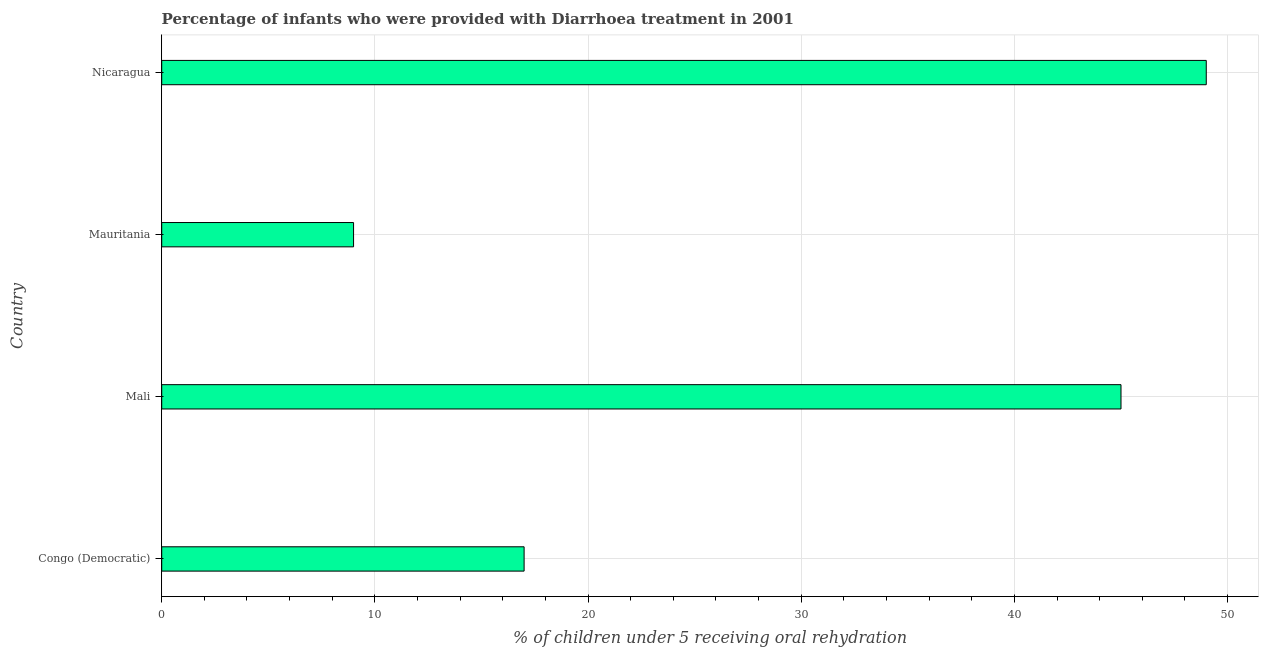What is the title of the graph?
Ensure brevity in your answer.  Percentage of infants who were provided with Diarrhoea treatment in 2001. What is the label or title of the X-axis?
Keep it short and to the point. % of children under 5 receiving oral rehydration. Across all countries, what is the maximum percentage of children who were provided with treatment diarrhoea?
Your answer should be compact. 49. Across all countries, what is the minimum percentage of children who were provided with treatment diarrhoea?
Keep it short and to the point. 9. In which country was the percentage of children who were provided with treatment diarrhoea maximum?
Offer a very short reply. Nicaragua. In which country was the percentage of children who were provided with treatment diarrhoea minimum?
Ensure brevity in your answer.  Mauritania. What is the sum of the percentage of children who were provided with treatment diarrhoea?
Your answer should be very brief. 120. What is the difference between the percentage of children who were provided with treatment diarrhoea in Congo (Democratic) and Nicaragua?
Provide a succinct answer. -32. What is the average percentage of children who were provided with treatment diarrhoea per country?
Make the answer very short. 30. What is the median percentage of children who were provided with treatment diarrhoea?
Make the answer very short. 31. In how many countries, is the percentage of children who were provided with treatment diarrhoea greater than 30 %?
Provide a succinct answer. 2. What is the ratio of the percentage of children who were provided with treatment diarrhoea in Mali to that in Nicaragua?
Keep it short and to the point. 0.92. Is the percentage of children who were provided with treatment diarrhoea in Congo (Democratic) less than that in Mauritania?
Offer a very short reply. No. Is the difference between the percentage of children who were provided with treatment diarrhoea in Congo (Democratic) and Mali greater than the difference between any two countries?
Offer a very short reply. No. What is the difference between the highest and the second highest percentage of children who were provided with treatment diarrhoea?
Provide a short and direct response. 4. How many bars are there?
Your answer should be very brief. 4. Are all the bars in the graph horizontal?
Offer a terse response. Yes. Are the values on the major ticks of X-axis written in scientific E-notation?
Offer a terse response. No. What is the % of children under 5 receiving oral rehydration in Congo (Democratic)?
Make the answer very short. 17. What is the % of children under 5 receiving oral rehydration of Mali?
Provide a short and direct response. 45. What is the difference between the % of children under 5 receiving oral rehydration in Congo (Democratic) and Mali?
Provide a succinct answer. -28. What is the difference between the % of children under 5 receiving oral rehydration in Congo (Democratic) and Mauritania?
Your answer should be compact. 8. What is the difference between the % of children under 5 receiving oral rehydration in Congo (Democratic) and Nicaragua?
Your answer should be compact. -32. What is the difference between the % of children under 5 receiving oral rehydration in Mali and Mauritania?
Your response must be concise. 36. What is the ratio of the % of children under 5 receiving oral rehydration in Congo (Democratic) to that in Mali?
Your answer should be very brief. 0.38. What is the ratio of the % of children under 5 receiving oral rehydration in Congo (Democratic) to that in Mauritania?
Provide a short and direct response. 1.89. What is the ratio of the % of children under 5 receiving oral rehydration in Congo (Democratic) to that in Nicaragua?
Your answer should be very brief. 0.35. What is the ratio of the % of children under 5 receiving oral rehydration in Mali to that in Nicaragua?
Keep it short and to the point. 0.92. What is the ratio of the % of children under 5 receiving oral rehydration in Mauritania to that in Nicaragua?
Provide a short and direct response. 0.18. 